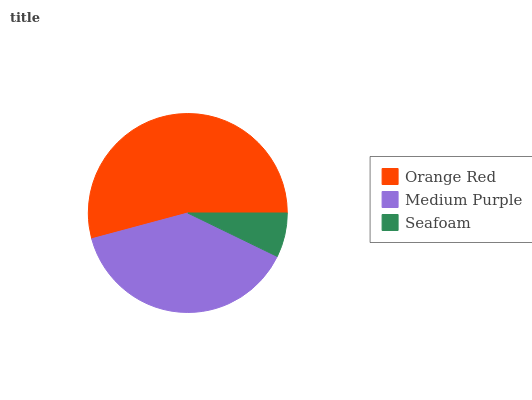Is Seafoam the minimum?
Answer yes or no. Yes. Is Orange Red the maximum?
Answer yes or no. Yes. Is Medium Purple the minimum?
Answer yes or no. No. Is Medium Purple the maximum?
Answer yes or no. No. Is Orange Red greater than Medium Purple?
Answer yes or no. Yes. Is Medium Purple less than Orange Red?
Answer yes or no. Yes. Is Medium Purple greater than Orange Red?
Answer yes or no. No. Is Orange Red less than Medium Purple?
Answer yes or no. No. Is Medium Purple the high median?
Answer yes or no. Yes. Is Medium Purple the low median?
Answer yes or no. Yes. Is Orange Red the high median?
Answer yes or no. No. Is Orange Red the low median?
Answer yes or no. No. 